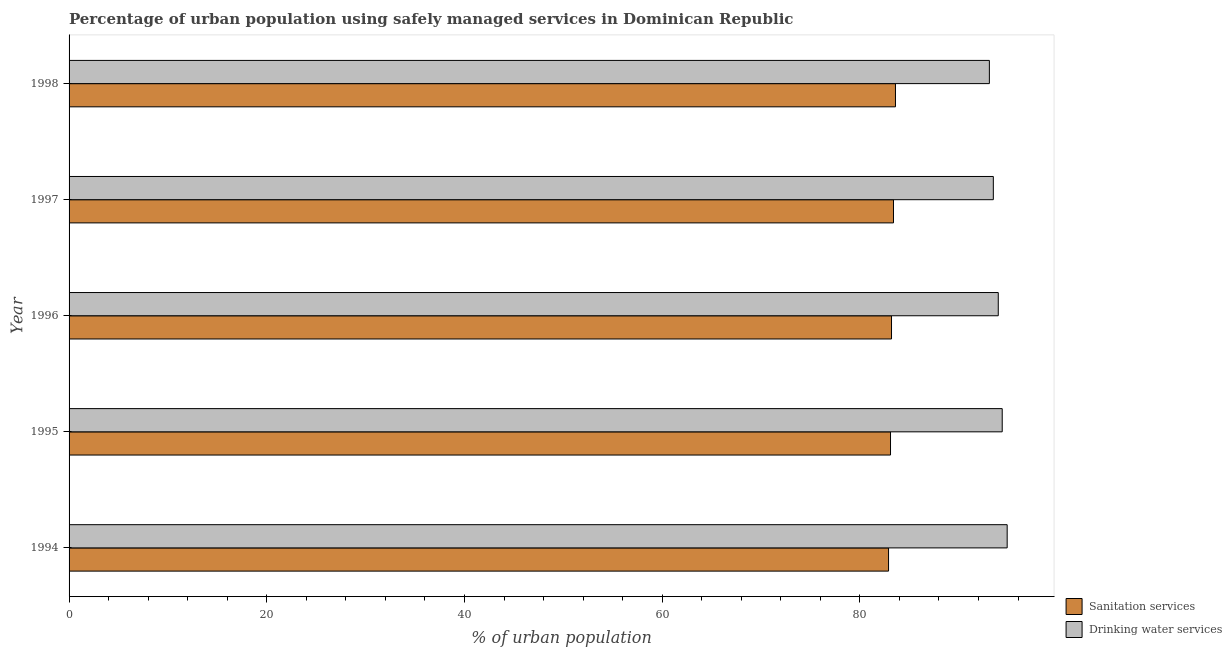How many groups of bars are there?
Provide a succinct answer. 5. Are the number of bars per tick equal to the number of legend labels?
Ensure brevity in your answer.  Yes. How many bars are there on the 3rd tick from the top?
Keep it short and to the point. 2. What is the percentage of urban population who used drinking water services in 1997?
Offer a very short reply. 93.5. Across all years, what is the maximum percentage of urban population who used drinking water services?
Your answer should be very brief. 94.9. Across all years, what is the minimum percentage of urban population who used sanitation services?
Your response must be concise. 82.9. In which year was the percentage of urban population who used drinking water services maximum?
Your response must be concise. 1994. In which year was the percentage of urban population who used drinking water services minimum?
Offer a very short reply. 1998. What is the total percentage of urban population who used sanitation services in the graph?
Offer a very short reply. 416.2. What is the difference between the percentage of urban population who used drinking water services in 1996 and that in 1997?
Make the answer very short. 0.5. What is the difference between the percentage of urban population who used sanitation services in 1997 and the percentage of urban population who used drinking water services in 1995?
Your answer should be very brief. -11. What is the average percentage of urban population who used drinking water services per year?
Provide a succinct answer. 93.98. In how many years, is the percentage of urban population who used drinking water services greater than 88 %?
Keep it short and to the point. 5. Is the difference between the percentage of urban population who used drinking water services in 1994 and 1996 greater than the difference between the percentage of urban population who used sanitation services in 1994 and 1996?
Offer a very short reply. Yes. What is the difference between the highest and the second highest percentage of urban population who used sanitation services?
Keep it short and to the point. 0.2. Is the sum of the percentage of urban population who used sanitation services in 1994 and 1995 greater than the maximum percentage of urban population who used drinking water services across all years?
Your answer should be compact. Yes. What does the 2nd bar from the top in 1996 represents?
Make the answer very short. Sanitation services. What does the 2nd bar from the bottom in 1994 represents?
Provide a short and direct response. Drinking water services. How many bars are there?
Offer a terse response. 10. Are all the bars in the graph horizontal?
Offer a terse response. Yes. How many years are there in the graph?
Offer a very short reply. 5. What is the difference between two consecutive major ticks on the X-axis?
Give a very brief answer. 20. Are the values on the major ticks of X-axis written in scientific E-notation?
Your response must be concise. No. Does the graph contain any zero values?
Make the answer very short. No. Does the graph contain grids?
Make the answer very short. No. How many legend labels are there?
Your response must be concise. 2. How are the legend labels stacked?
Provide a succinct answer. Vertical. What is the title of the graph?
Make the answer very short. Percentage of urban population using safely managed services in Dominican Republic. What is the label or title of the X-axis?
Provide a short and direct response. % of urban population. What is the label or title of the Y-axis?
Make the answer very short. Year. What is the % of urban population in Sanitation services in 1994?
Your answer should be very brief. 82.9. What is the % of urban population of Drinking water services in 1994?
Your answer should be compact. 94.9. What is the % of urban population in Sanitation services in 1995?
Offer a terse response. 83.1. What is the % of urban population of Drinking water services in 1995?
Your answer should be very brief. 94.4. What is the % of urban population in Sanitation services in 1996?
Make the answer very short. 83.2. What is the % of urban population in Drinking water services in 1996?
Offer a very short reply. 94. What is the % of urban population of Sanitation services in 1997?
Offer a very short reply. 83.4. What is the % of urban population in Drinking water services in 1997?
Your response must be concise. 93.5. What is the % of urban population of Sanitation services in 1998?
Offer a terse response. 83.6. What is the % of urban population in Drinking water services in 1998?
Make the answer very short. 93.1. Across all years, what is the maximum % of urban population of Sanitation services?
Keep it short and to the point. 83.6. Across all years, what is the maximum % of urban population in Drinking water services?
Your response must be concise. 94.9. Across all years, what is the minimum % of urban population in Sanitation services?
Give a very brief answer. 82.9. Across all years, what is the minimum % of urban population in Drinking water services?
Make the answer very short. 93.1. What is the total % of urban population of Sanitation services in the graph?
Give a very brief answer. 416.2. What is the total % of urban population in Drinking water services in the graph?
Your answer should be very brief. 469.9. What is the difference between the % of urban population of Drinking water services in 1994 and that in 1995?
Your answer should be very brief. 0.5. What is the difference between the % of urban population of Sanitation services in 1994 and that in 1996?
Give a very brief answer. -0.3. What is the difference between the % of urban population of Drinking water services in 1994 and that in 1996?
Provide a succinct answer. 0.9. What is the difference between the % of urban population of Sanitation services in 1994 and that in 1997?
Your answer should be compact. -0.5. What is the difference between the % of urban population in Drinking water services in 1994 and that in 1997?
Provide a short and direct response. 1.4. What is the difference between the % of urban population of Sanitation services in 1994 and that in 1998?
Your answer should be compact. -0.7. What is the difference between the % of urban population in Drinking water services in 1994 and that in 1998?
Provide a short and direct response. 1.8. What is the difference between the % of urban population in Sanitation services in 1995 and that in 1996?
Provide a short and direct response. -0.1. What is the difference between the % of urban population of Drinking water services in 1995 and that in 1996?
Offer a terse response. 0.4. What is the difference between the % of urban population in Drinking water services in 1995 and that in 1997?
Your response must be concise. 0.9. What is the difference between the % of urban population of Sanitation services in 1995 and that in 1998?
Your answer should be compact. -0.5. What is the difference between the % of urban population in Drinking water services in 1995 and that in 1998?
Your response must be concise. 1.3. What is the difference between the % of urban population in Sanitation services in 1994 and the % of urban population in Drinking water services in 1996?
Your answer should be very brief. -11.1. What is the difference between the % of urban population of Sanitation services in 1994 and the % of urban population of Drinking water services in 1997?
Your response must be concise. -10.6. What is the difference between the % of urban population of Sanitation services in 1994 and the % of urban population of Drinking water services in 1998?
Keep it short and to the point. -10.2. What is the difference between the % of urban population in Sanitation services in 1995 and the % of urban population in Drinking water services in 1996?
Your response must be concise. -10.9. What is the difference between the % of urban population of Sanitation services in 1995 and the % of urban population of Drinking water services in 1997?
Make the answer very short. -10.4. What is the difference between the % of urban population in Sanitation services in 1995 and the % of urban population in Drinking water services in 1998?
Your answer should be compact. -10. What is the difference between the % of urban population of Sanitation services in 1996 and the % of urban population of Drinking water services in 1998?
Your answer should be very brief. -9.9. What is the average % of urban population of Sanitation services per year?
Keep it short and to the point. 83.24. What is the average % of urban population of Drinking water services per year?
Ensure brevity in your answer.  93.98. In the year 1995, what is the difference between the % of urban population in Sanitation services and % of urban population in Drinking water services?
Provide a succinct answer. -11.3. In the year 1996, what is the difference between the % of urban population of Sanitation services and % of urban population of Drinking water services?
Provide a short and direct response. -10.8. In the year 1998, what is the difference between the % of urban population in Sanitation services and % of urban population in Drinking water services?
Provide a short and direct response. -9.5. What is the ratio of the % of urban population in Sanitation services in 1994 to that in 1995?
Give a very brief answer. 1. What is the ratio of the % of urban population of Drinking water services in 1994 to that in 1995?
Your response must be concise. 1.01. What is the ratio of the % of urban population of Drinking water services in 1994 to that in 1996?
Keep it short and to the point. 1.01. What is the ratio of the % of urban population in Sanitation services in 1994 to that in 1997?
Your answer should be very brief. 0.99. What is the ratio of the % of urban population in Drinking water services in 1994 to that in 1998?
Ensure brevity in your answer.  1.02. What is the ratio of the % of urban population of Sanitation services in 1995 to that in 1996?
Your response must be concise. 1. What is the ratio of the % of urban population of Drinking water services in 1995 to that in 1997?
Provide a succinct answer. 1.01. What is the ratio of the % of urban population of Sanitation services in 1995 to that in 1998?
Offer a terse response. 0.99. What is the ratio of the % of urban population of Drinking water services in 1996 to that in 1997?
Give a very brief answer. 1.01. What is the ratio of the % of urban population in Drinking water services in 1996 to that in 1998?
Offer a very short reply. 1.01. What is the ratio of the % of urban population of Drinking water services in 1997 to that in 1998?
Your answer should be compact. 1. What is the difference between the highest and the second highest % of urban population of Sanitation services?
Offer a very short reply. 0.2. What is the difference between the highest and the second highest % of urban population in Drinking water services?
Make the answer very short. 0.5. 